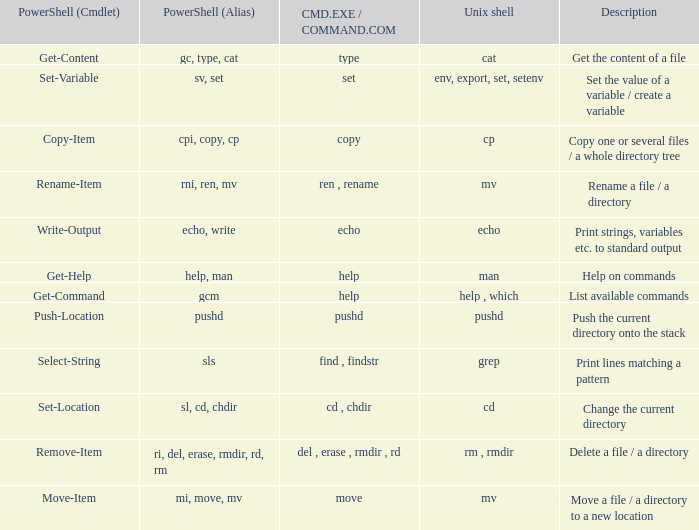What are the names of all unix shell with PowerShell (Cmdlet) of select-string? Grep. 